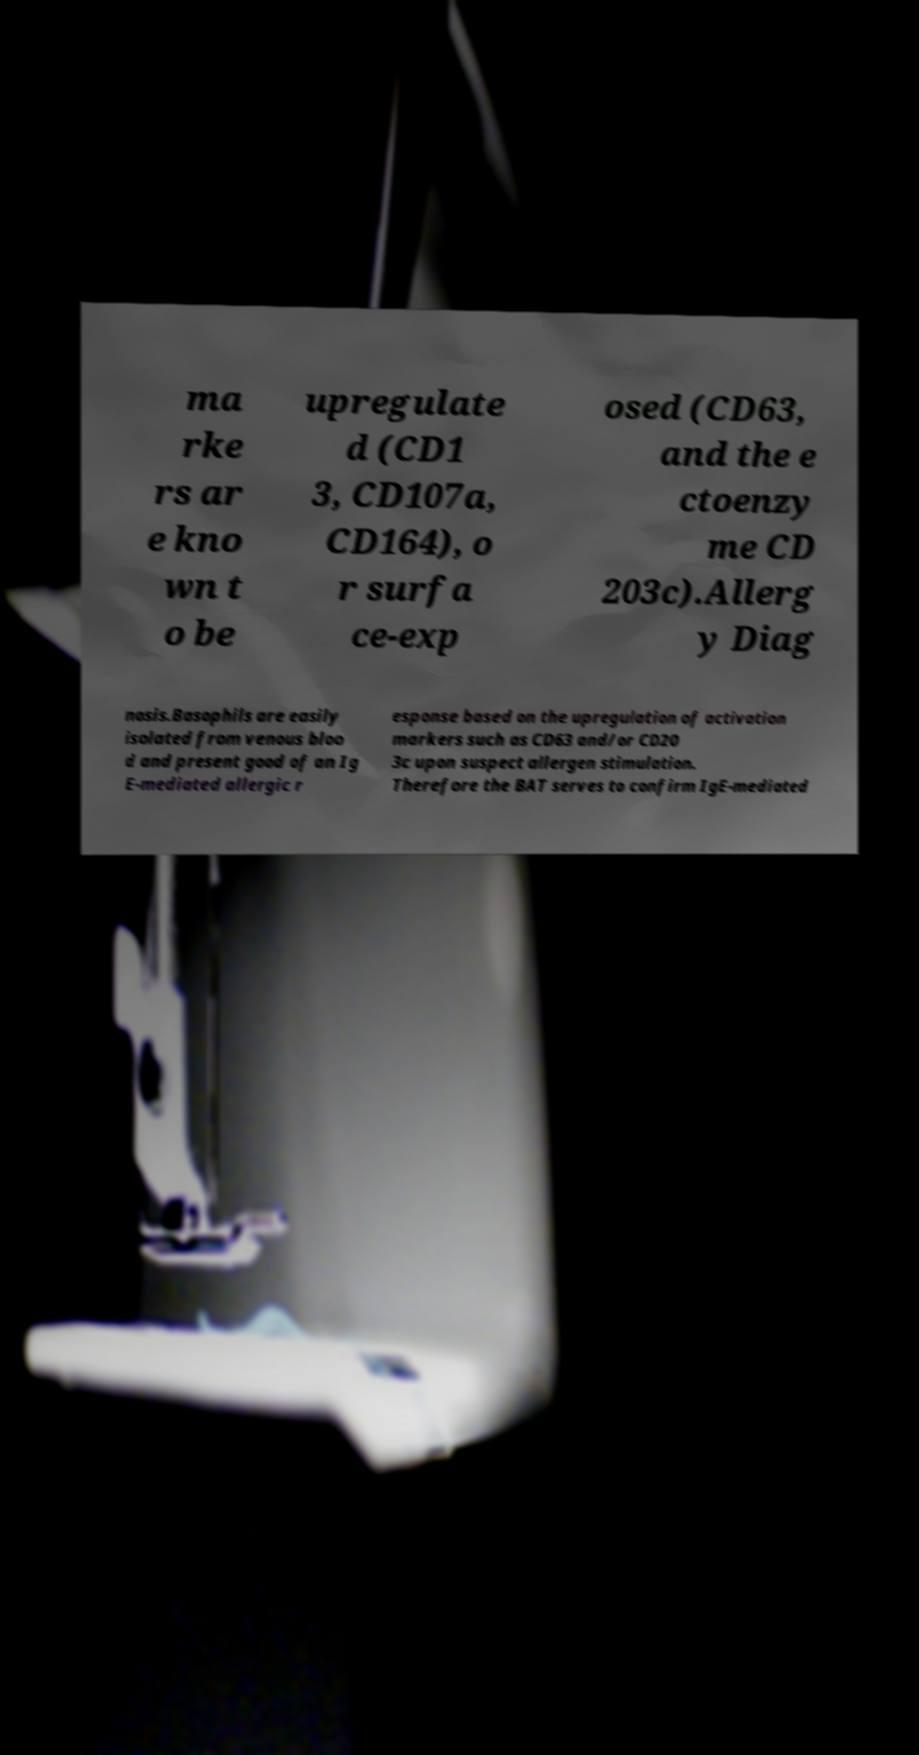Please identify and transcribe the text found in this image. ma rke rs ar e kno wn t o be upregulate d (CD1 3, CD107a, CD164), o r surfa ce-exp osed (CD63, and the e ctoenzy me CD 203c).Allerg y Diag nosis.Basophils are easily isolated from venous bloo d and present good of an Ig E-mediated allergic r esponse based on the upregulation of activation markers such as CD63 and/or CD20 3c upon suspect allergen stimulation. Therefore the BAT serves to confirm IgE-mediated 